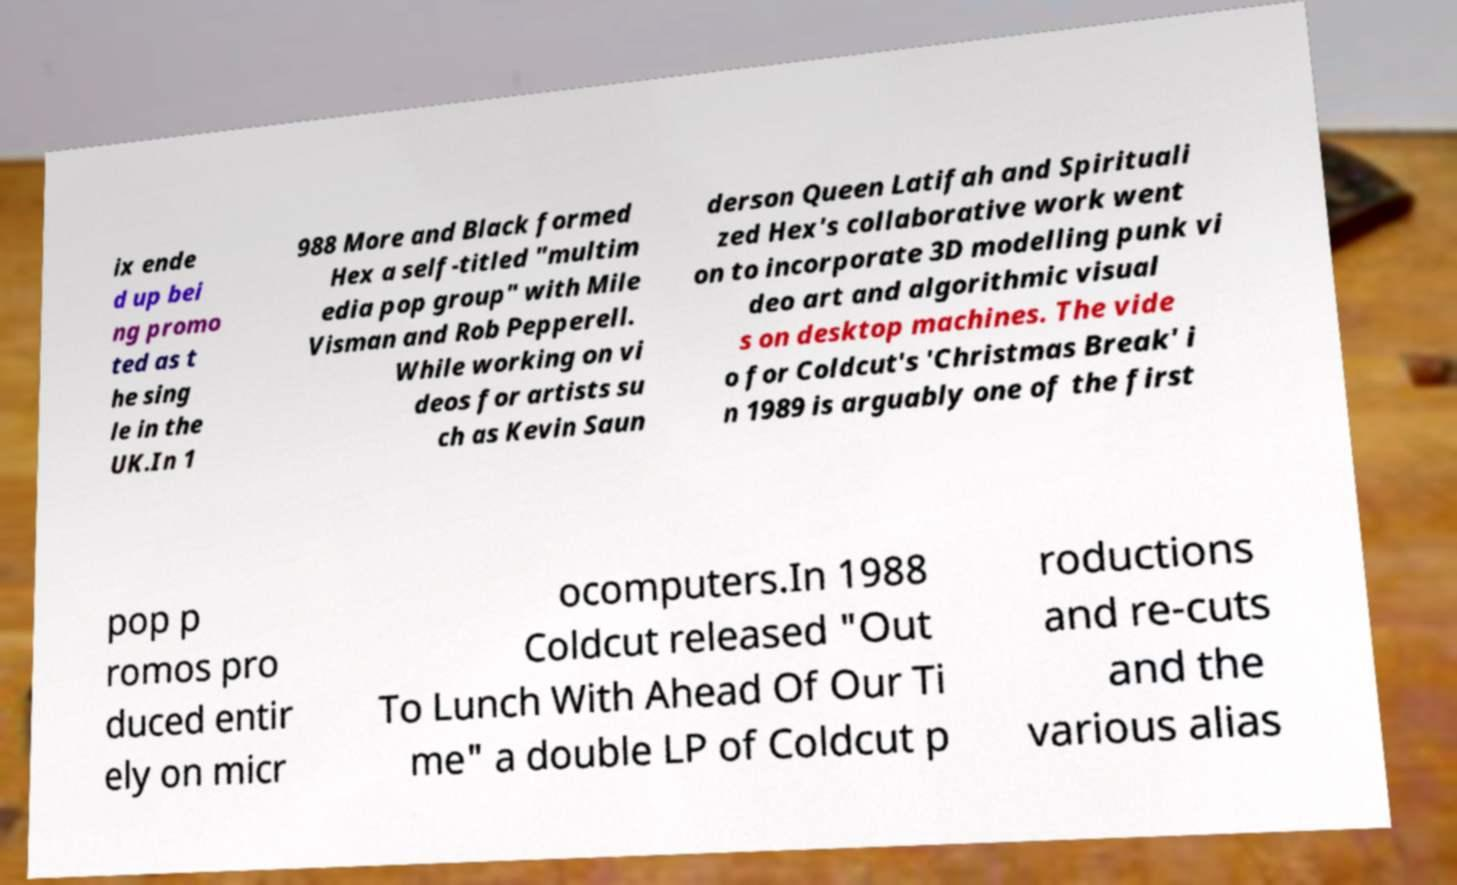Please read and relay the text visible in this image. What does it say? ix ende d up bei ng promo ted as t he sing le in the UK.In 1 988 More and Black formed Hex a self-titled "multim edia pop group" with Mile Visman and Rob Pepperell. While working on vi deos for artists su ch as Kevin Saun derson Queen Latifah and Spirituali zed Hex's collaborative work went on to incorporate 3D modelling punk vi deo art and algorithmic visual s on desktop machines. The vide o for Coldcut's 'Christmas Break' i n 1989 is arguably one of the first pop p romos pro duced entir ely on micr ocomputers.In 1988 Coldcut released "Out To Lunch With Ahead Of Our Ti me" a double LP of Coldcut p roductions and re-cuts and the various alias 